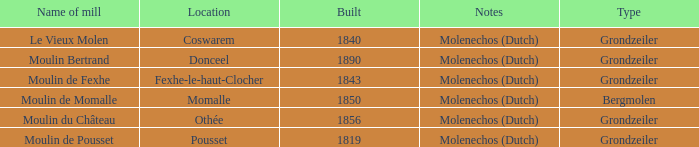What is year Built of the Moulin de Momalle Mill? 1850.0. 